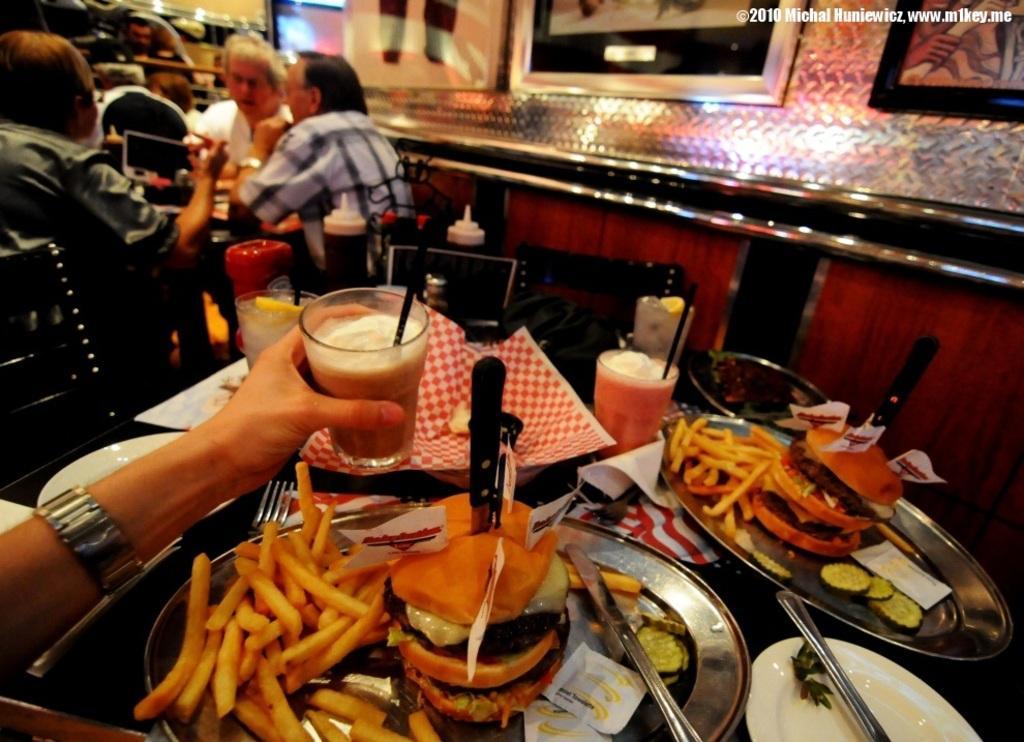Please provide a concise description of this image. This is the table with the plates, glasses, forks, papers and few other things on it. On the left side of the image, I can see a person´a hand holding a glass. There are three people sitting on the chairs. These are the photo frames, which are attached to the wall. These plates contain burgers and french fries. This is the watermark on the image. 